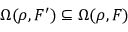<formula> <loc_0><loc_0><loc_500><loc_500>\Omega ( \rho , F ^ { \prime } ) \subseteq \Omega ( \rho , F )</formula> 